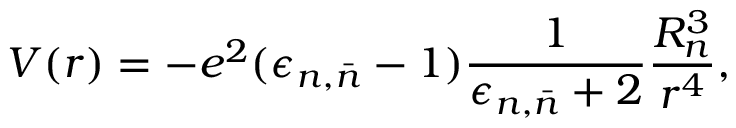<formula> <loc_0><loc_0><loc_500><loc_500>V ( r ) = - e ^ { 2 } ( \epsilon _ { n , \bar { n } } - 1 ) \frac { 1 } { \epsilon _ { n , \bar { n } } + 2 } \frac { R _ { n } ^ { 3 } } { r ^ { 4 } } ,</formula> 